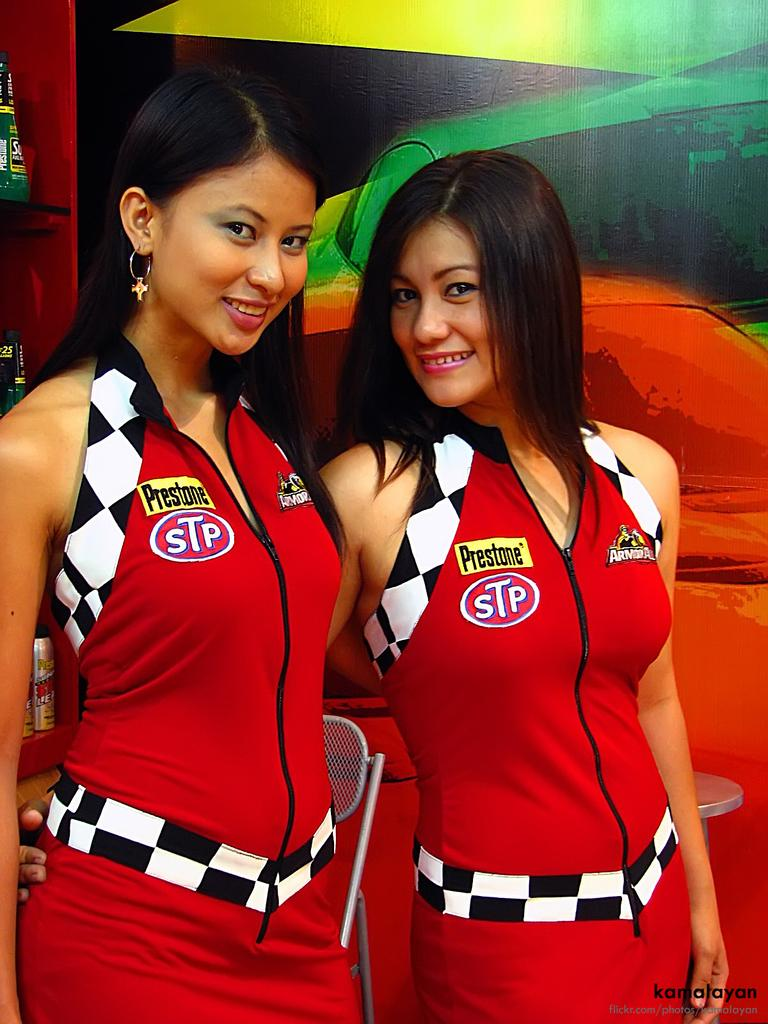<image>
Offer a succinct explanation of the picture presented. Two young models wear uniforms with the STP logo on them. 